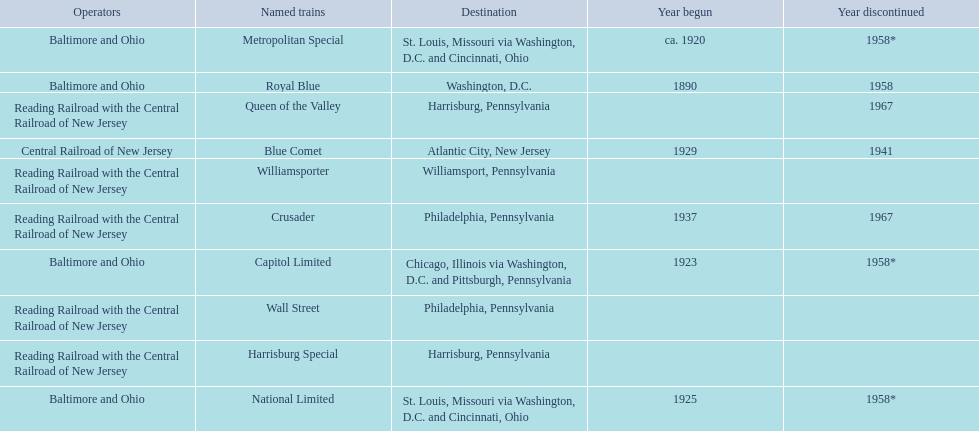What are the destinations of the central railroad of new jersey terminal? Chicago, Illinois via Washington, D.C. and Pittsburgh, Pennsylvania, St. Louis, Missouri via Washington, D.C. and Cincinnati, Ohio, St. Louis, Missouri via Washington, D.C. and Cincinnati, Ohio, Washington, D.C., Atlantic City, New Jersey, Philadelphia, Pennsylvania, Harrisburg, Pennsylvania, Harrisburg, Pennsylvania, Philadelphia, Pennsylvania, Williamsport, Pennsylvania. Which of these destinations is at the top of the list? Chicago, Illinois via Washington, D.C. and Pittsburgh, Pennsylvania. 